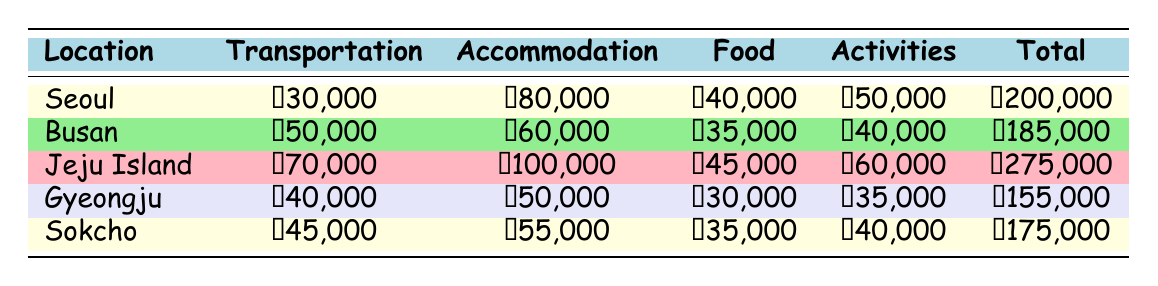What's the total transportation cost for Jeju Island? The transportation cost listed for Jeju Island in the table is ₩70,000.
Answer: ₩70,000 What is the total expense for Gyeongju? The total expense for Gyeongju, as shown in the table, is ₩155,000.
Answer: ₩155,000 Which location has the highest accommodation cost? By reviewing the accommodation costs in the table, Jeju Island has the highest accommodation cost at ₩100,000.
Answer: Jeju Island What is the difference in total expenses between Seoul and Busan? The total expenses for Seoul is ₩200,000 and for Busan is ₩185,000. The difference is ₩200,000 - ₩185,000 = ₩15,000.
Answer: ₩15,000 Is the food expense in Sokcho higher than in Gyeongju? The food expense for Sokcho is ₩35,000 and for Gyeongju is ₩30,000. Since ₩35,000 is greater than ₩30,000, the answer is yes.
Answer: Yes What's the average total expense of all locations listed in the table? The total expenses are ₩200,000 + ₩185,000 + ₩275,000 + ₩155,000 + ₩175,000 = ₩1,090,000. The average expense is ₩1,090,000 divided by 5 locations, which equals ₩218,000.
Answer: ₩218,000 Which location has the cheapest total expense? Gyeongju has the cheapest total expense at ₩155,000 when compared to all other locations in the table.
Answer: Gyeongju What is the total cost for transportation and accommodation combined for Busan? The transportation cost for Busan is ₩50,000 and accommodation is ₩60,000. Combined, this is ₩50,000 + ₩60,000 = ₩110,000.
Answer: ₩110,000 Did Jeju Island's activities cost more than the combined food and activities cost of Gyeongju? For Jeju Island, the activities cost is ₩60,000. For Gyeongju, the food is ₩30,000 and activities are ₩35,000, which adds up to ₩30,000 + ₩35,000 = ₩65,000. Since ₩60,000 is less than ₩65,000, the answer is no.
Answer: No 